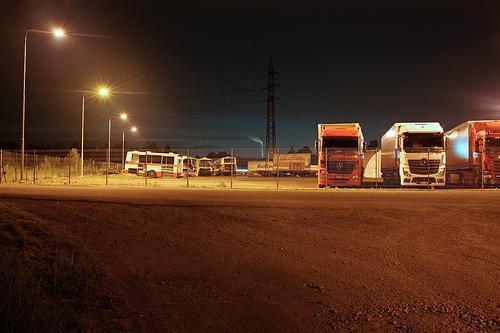How many cabs are facing forward?
Give a very brief answer. 3. How many lights are glowing?
Give a very brief answer. 4. 